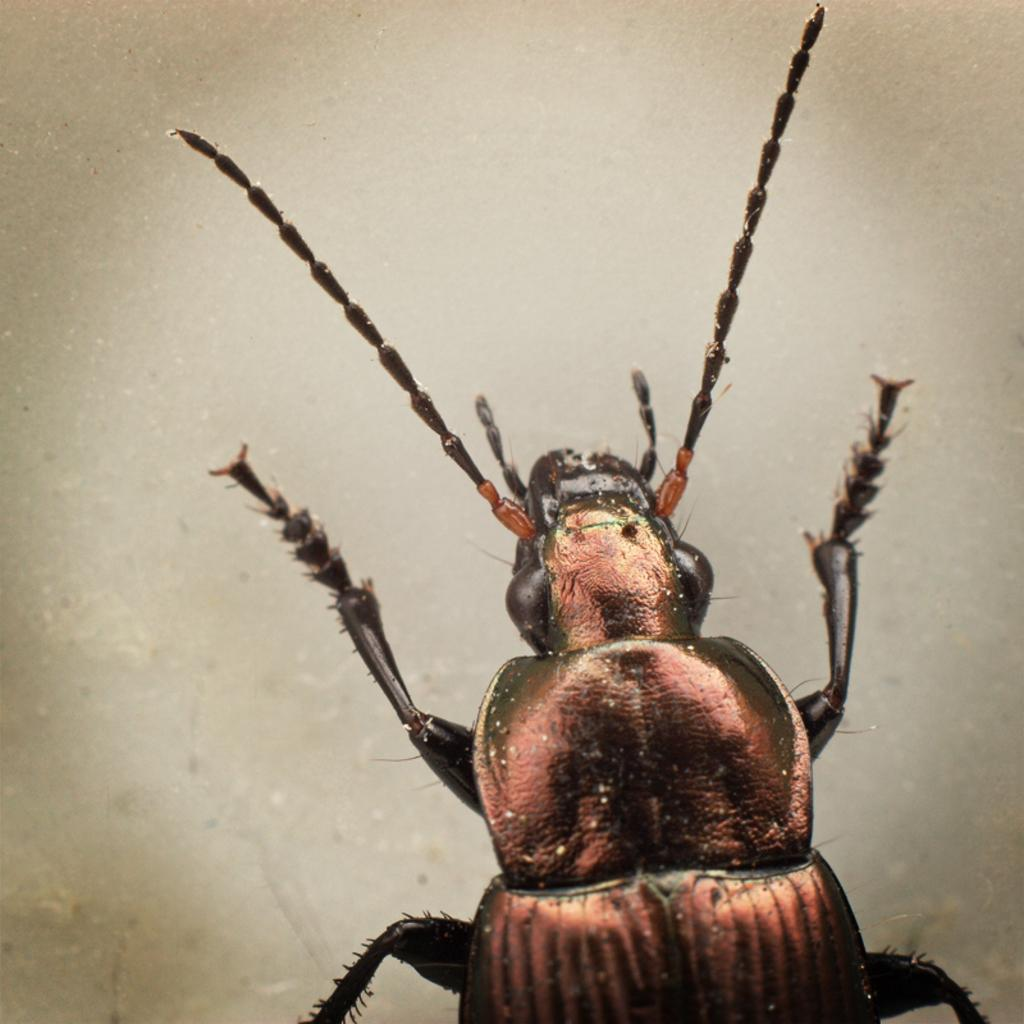What is present on the floor in the image? There is a bug in the image. Can you describe the bug's position in the image? The bug is standing on the floor. What type of company is located in the library in the image? There is no company or library present in the image; it only features a bug standing on the floor. 